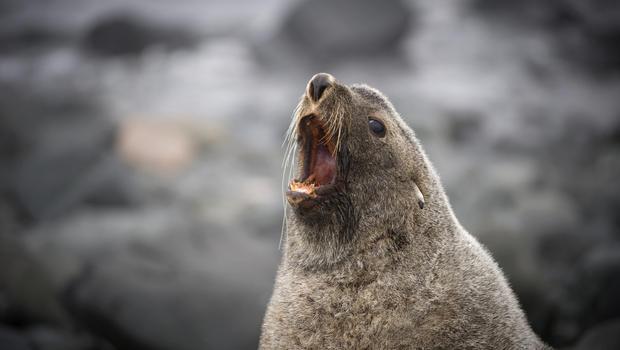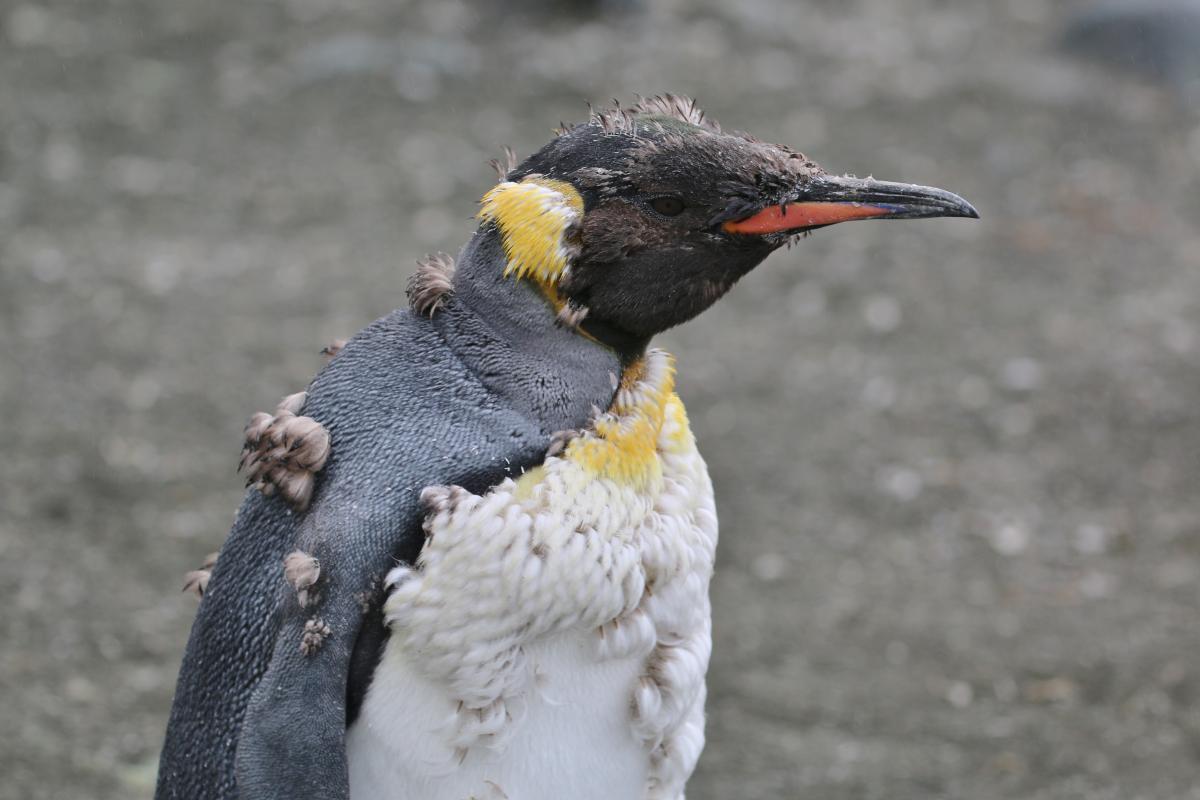The first image is the image on the left, the second image is the image on the right. Examine the images to the left and right. Is the description "a penguin has molting feathers" accurate? Answer yes or no. Yes. The first image is the image on the left, the second image is the image on the right. Evaluate the accuracy of this statement regarding the images: "There is exactly one seal.". Is it true? Answer yes or no. Yes. 